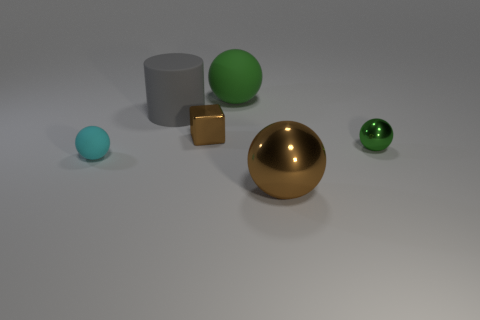There is a tiny metal object to the right of the big ball in front of the cyan sphere; what shape is it?
Ensure brevity in your answer.  Sphere. There is a green ball that is to the left of the green sphere that is right of the green ball on the left side of the big brown thing; what is its size?
Your answer should be very brief. Large. What color is the large shiny object that is the same shape as the cyan rubber thing?
Keep it short and to the point. Brown. Do the matte cylinder and the brown metallic ball have the same size?
Keep it short and to the point. Yes. What material is the brown object that is to the left of the large brown object?
Provide a succinct answer. Metal. How many other things are the same shape as the big brown object?
Offer a very short reply. 3. Do the green metal thing and the cyan matte thing have the same shape?
Provide a short and direct response. Yes. There is a cylinder; are there any big gray cylinders left of it?
Provide a short and direct response. No. How many things are either big rubber spheres or tiny blue rubber cylinders?
Offer a terse response. 1. What number of other things are the same size as the rubber cylinder?
Keep it short and to the point. 2. 